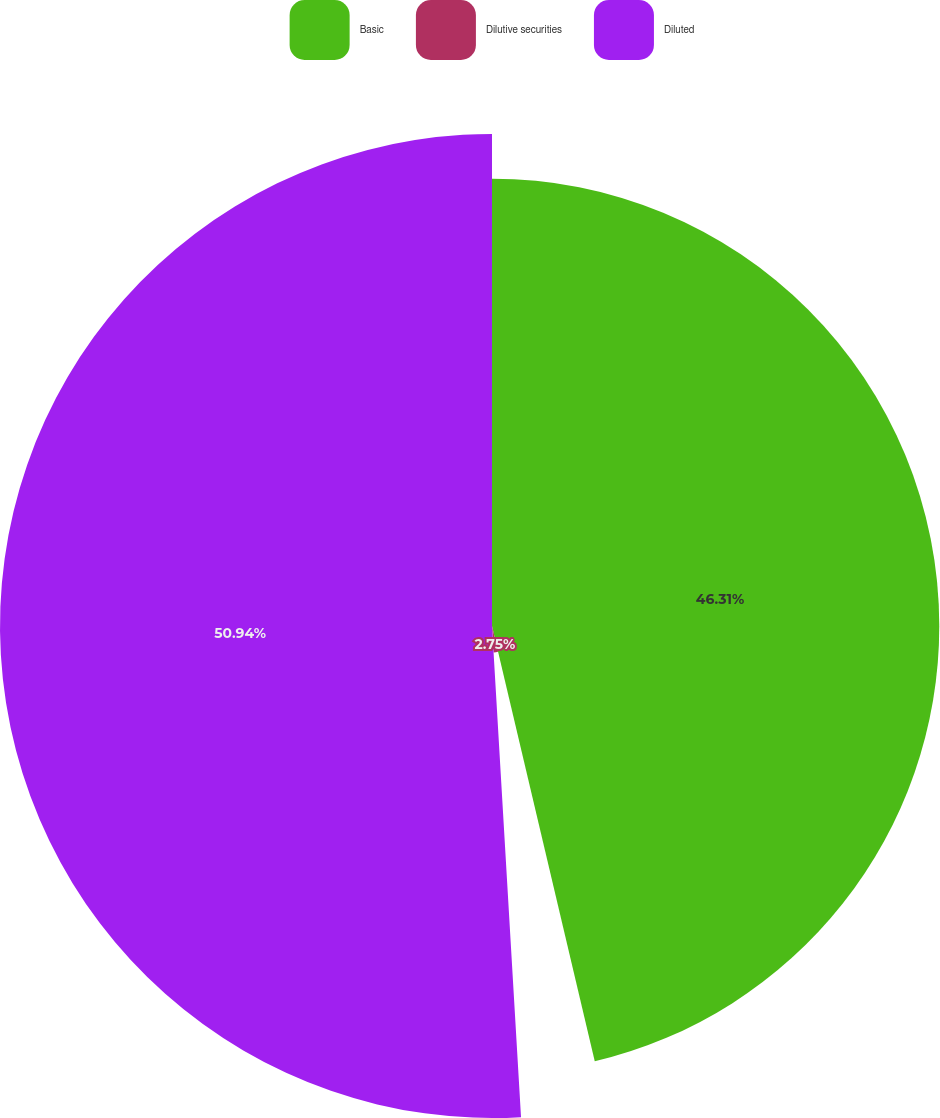Convert chart to OTSL. <chart><loc_0><loc_0><loc_500><loc_500><pie_chart><fcel>Basic<fcel>Dilutive securities<fcel>Diluted<nl><fcel>46.31%<fcel>2.75%<fcel>50.94%<nl></chart> 